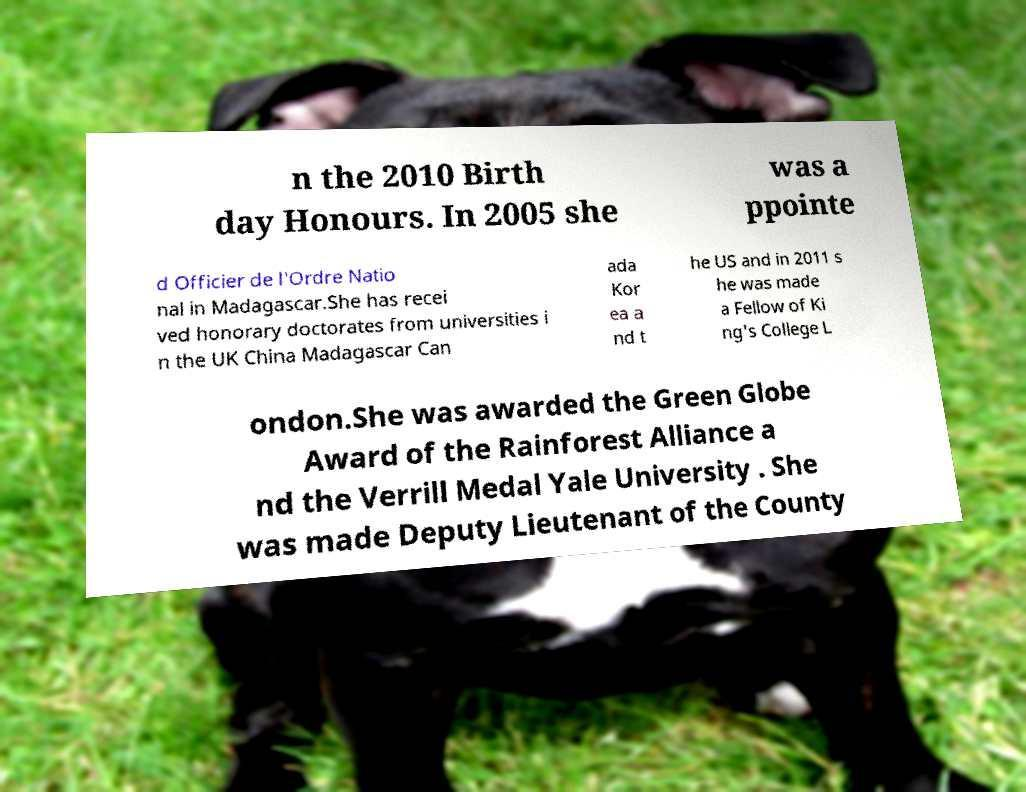There's text embedded in this image that I need extracted. Can you transcribe it verbatim? n the 2010 Birth day Honours. In 2005 she was a ppointe d Officier de l'Ordre Natio nal in Madagascar.She has recei ved honorary doctorates from universities i n the UK China Madagascar Can ada Kor ea a nd t he US and in 2011 s he was made a Fellow of Ki ng's College L ondon.She was awarded the Green Globe Award of the Rainforest Alliance a nd the Verrill Medal Yale University . She was made Deputy Lieutenant of the County 